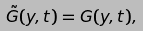<formula> <loc_0><loc_0><loc_500><loc_500>\tilde { G } ( y , t ) = G ( y , t ) ,</formula> 